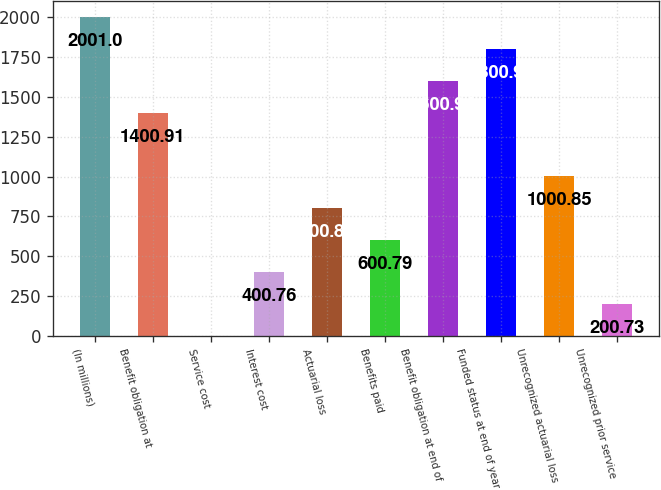Convert chart to OTSL. <chart><loc_0><loc_0><loc_500><loc_500><bar_chart><fcel>(In millions)<fcel>Benefit obligation at<fcel>Service cost<fcel>Interest cost<fcel>Actuarial loss<fcel>Benefits paid<fcel>Benefit obligation at end of<fcel>Funded status at end of year<fcel>Unrecognized actuarial loss<fcel>Unrecognized prior service<nl><fcel>2001<fcel>1400.91<fcel>0.7<fcel>400.76<fcel>800.82<fcel>600.79<fcel>1600.94<fcel>1800.97<fcel>1000.85<fcel>200.73<nl></chart> 